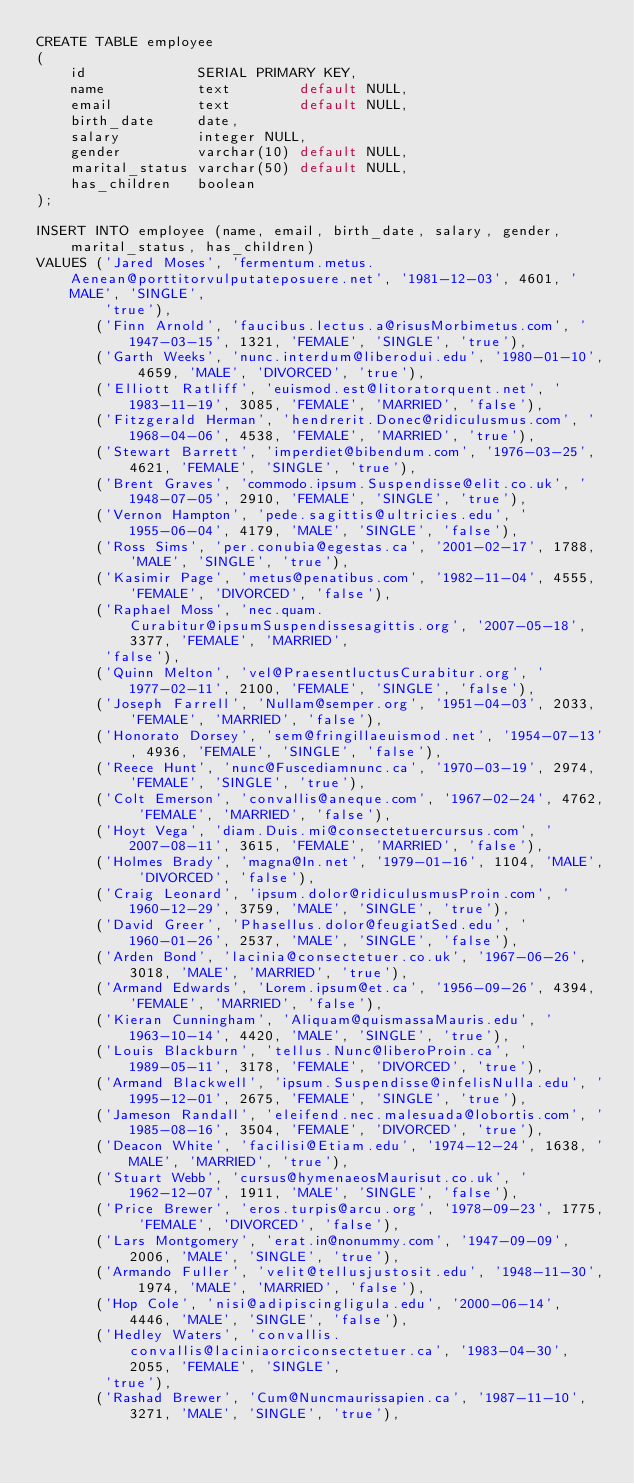Convert code to text. <code><loc_0><loc_0><loc_500><loc_500><_SQL_>CREATE TABLE employee
(
    id             SERIAL PRIMARY KEY,
    name           text        default NULL,
    email          text        default NULL,
    birth_date     date,
    salary         integer NULL,
    gender         varchar(10) default NULL,
    marital_status varchar(50) default NULL,
    has_children   boolean
);

INSERT INTO employee (name, email, birth_date, salary, gender, marital_status, has_children)
VALUES ('Jared Moses', 'fermentum.metus.Aenean@porttitorvulputateposuere.net', '1981-12-03', 4601, 'MALE', 'SINGLE',
        'true'),
       ('Finn Arnold', 'faucibus.lectus.a@risusMorbimetus.com', '1947-03-15', 1321, 'FEMALE', 'SINGLE', 'true'),
       ('Garth Weeks', 'nunc.interdum@liberodui.edu', '1980-01-10', 4659, 'MALE', 'DIVORCED', 'true'),
       ('Elliott Ratliff', 'euismod.est@litoratorquent.net', '1983-11-19', 3085, 'FEMALE', 'MARRIED', 'false'),
       ('Fitzgerald Herman', 'hendrerit.Donec@ridiculusmus.com', '1968-04-06', 4538, 'FEMALE', 'MARRIED', 'true'),
       ('Stewart Barrett', 'imperdiet@bibendum.com', '1976-03-25', 4621, 'FEMALE', 'SINGLE', 'true'),
       ('Brent Graves', 'commodo.ipsum.Suspendisse@elit.co.uk', '1948-07-05', 2910, 'FEMALE', 'SINGLE', 'true'),
       ('Vernon Hampton', 'pede.sagittis@ultricies.edu', '1955-06-04', 4179, 'MALE', 'SINGLE', 'false'),
       ('Ross Sims', 'per.conubia@egestas.ca', '2001-02-17', 1788, 'MALE', 'SINGLE', 'true'),
       ('Kasimir Page', 'metus@penatibus.com', '1982-11-04', 4555, 'FEMALE', 'DIVORCED', 'false'),
       ('Raphael Moss', 'nec.quam.Curabitur@ipsumSuspendissesagittis.org', '2007-05-18', 3377, 'FEMALE', 'MARRIED',
        'false'),
       ('Quinn Melton', 'vel@PraesentluctusCurabitur.org', '1977-02-11', 2100, 'FEMALE', 'SINGLE', 'false'),
       ('Joseph Farrell', 'Nullam@semper.org', '1951-04-03', 2033, 'FEMALE', 'MARRIED', 'false'),
       ('Honorato Dorsey', 'sem@fringillaeuismod.net', '1954-07-13', 4936, 'FEMALE', 'SINGLE', 'false'),
       ('Reece Hunt', 'nunc@Fuscediamnunc.ca', '1970-03-19', 2974, 'FEMALE', 'SINGLE', 'true'),
       ('Colt Emerson', 'convallis@aneque.com', '1967-02-24', 4762, 'FEMALE', 'MARRIED', 'false'),
       ('Hoyt Vega', 'diam.Duis.mi@consectetuercursus.com', '2007-08-11', 3615, 'FEMALE', 'MARRIED', 'false'),
       ('Holmes Brady', 'magna@In.net', '1979-01-16', 1104, 'MALE', 'DIVORCED', 'false'),
       ('Craig Leonard', 'ipsum.dolor@ridiculusmusProin.com', '1960-12-29', 3759, 'MALE', 'SINGLE', 'true'),
       ('David Greer', 'Phasellus.dolor@feugiatSed.edu', '1960-01-26', 2537, 'MALE', 'SINGLE', 'false'),
       ('Arden Bond', 'lacinia@consectetuer.co.uk', '1967-06-26', 3018, 'MALE', 'MARRIED', 'true'),
       ('Armand Edwards', 'Lorem.ipsum@et.ca', '1956-09-26', 4394, 'FEMALE', 'MARRIED', 'false'),
       ('Kieran Cunningham', 'Aliquam@quismassaMauris.edu', '1963-10-14', 4420, 'MALE', 'SINGLE', 'true'),
       ('Louis Blackburn', 'tellus.Nunc@liberoProin.ca', '1989-05-11', 3178, 'FEMALE', 'DIVORCED', 'true'),
       ('Armand Blackwell', 'ipsum.Suspendisse@infelisNulla.edu', '1995-12-01', 2675, 'FEMALE', 'SINGLE', 'true'),
       ('Jameson Randall', 'eleifend.nec.malesuada@lobortis.com', '1985-08-16', 3504, 'FEMALE', 'DIVORCED', 'true'),
       ('Deacon White', 'facilisi@Etiam.edu', '1974-12-24', 1638, 'MALE', 'MARRIED', 'true'),
       ('Stuart Webb', 'cursus@hymenaeosMaurisut.co.uk', '1962-12-07', 1911, 'MALE', 'SINGLE', 'false'),
       ('Price Brewer', 'eros.turpis@arcu.org', '1978-09-23', 1775, 'FEMALE', 'DIVORCED', 'false'),
       ('Lars Montgomery', 'erat.in@nonummy.com', '1947-09-09', 2006, 'MALE', 'SINGLE', 'true'),
       ('Armando Fuller', 'velit@tellusjustosit.edu', '1948-11-30', 1974, 'MALE', 'MARRIED', 'false'),
       ('Hop Cole', 'nisi@adipiscingligula.edu', '2000-06-14', 4446, 'MALE', 'SINGLE', 'false'),
       ('Hedley Waters', 'convallis.convallis@laciniaorciconsectetuer.ca', '1983-04-30', 2055, 'FEMALE', 'SINGLE',
        'true'),
       ('Rashad Brewer', 'Cum@Nuncmaurissapien.ca', '1987-11-10', 3271, 'MALE', 'SINGLE', 'true'),</code> 